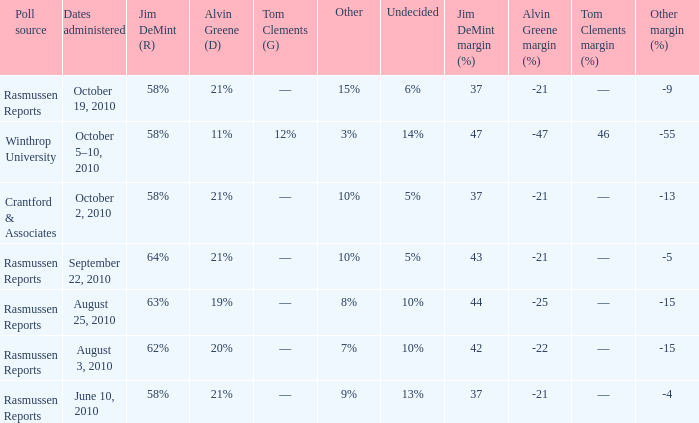What was the vote for Alvin Green when other was 9%? 21%. 